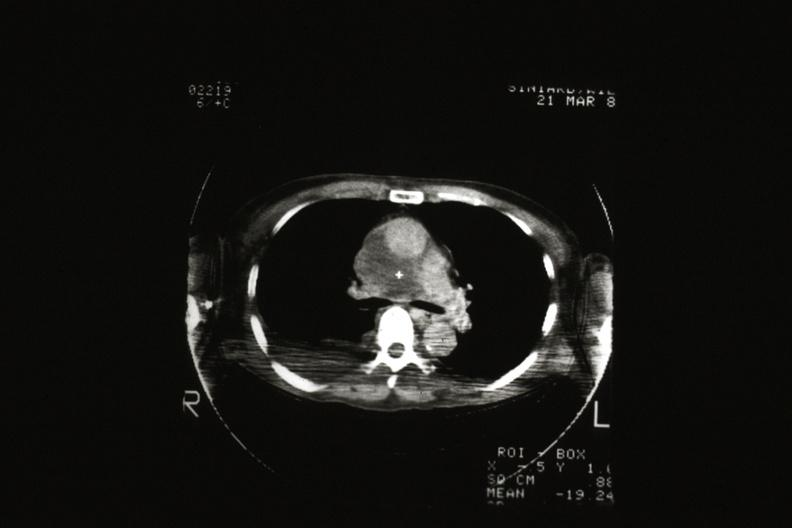s metastatic carcinoma present?
Answer the question using a single word or phrase. No 